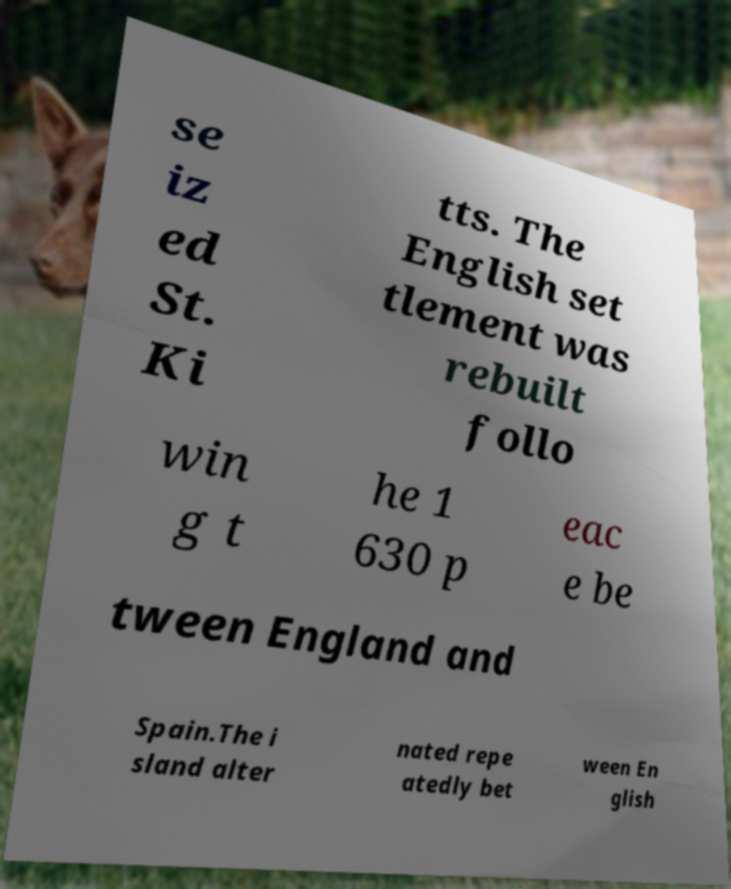What messages or text are displayed in this image? I need them in a readable, typed format. se iz ed St. Ki tts. The English set tlement was rebuilt follo win g t he 1 630 p eac e be tween England and Spain.The i sland alter nated repe atedly bet ween En glish 